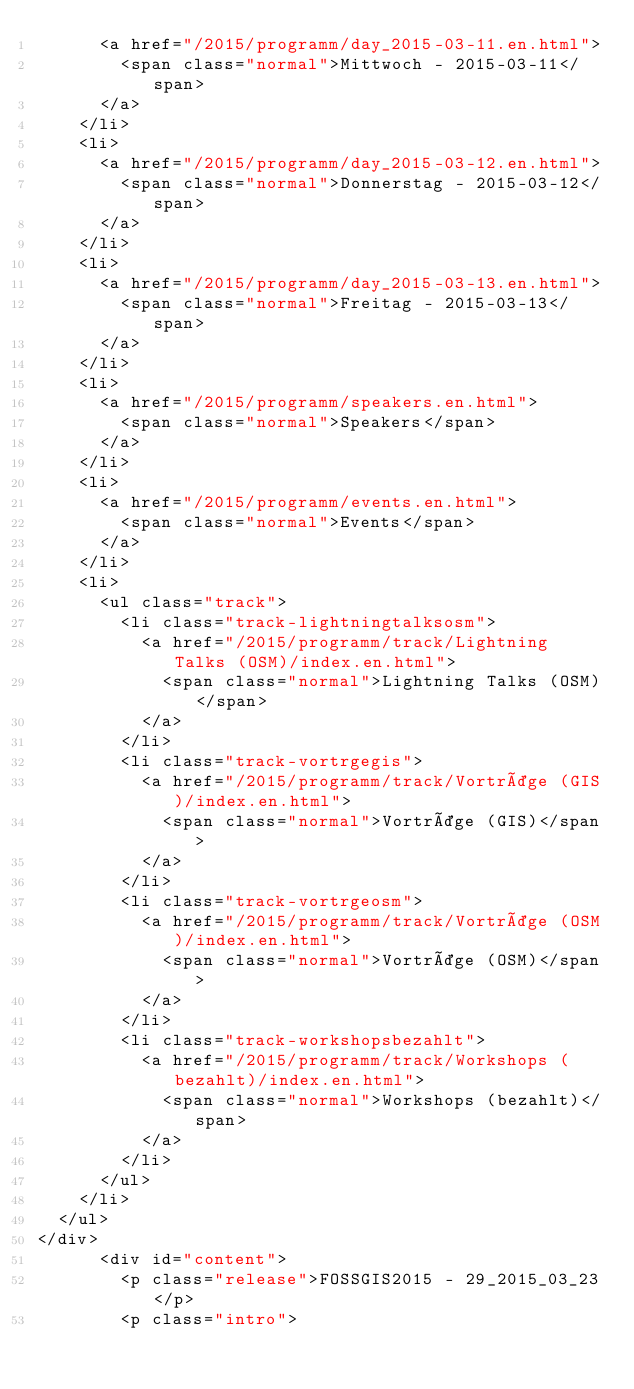Convert code to text. <code><loc_0><loc_0><loc_500><loc_500><_HTML_>      <a href="/2015/programm/day_2015-03-11.en.html">
        <span class="normal">Mittwoch - 2015-03-11</span>
      </a>
    </li>
    <li>
      <a href="/2015/programm/day_2015-03-12.en.html">
        <span class="normal">Donnerstag - 2015-03-12</span>
      </a>
    </li>
    <li>
      <a href="/2015/programm/day_2015-03-13.en.html">
        <span class="normal">Freitag - 2015-03-13</span>
      </a>
    </li>
    <li>
      <a href="/2015/programm/speakers.en.html">
        <span class="normal">Speakers</span>
      </a>
    </li>
    <li>
      <a href="/2015/programm/events.en.html">
        <span class="normal">Events</span>
      </a>
    </li>
    <li>
      <ul class="track">
        <li class="track-lightningtalksosm">
          <a href="/2015/programm/track/Lightning Talks (OSM)/index.en.html">
            <span class="normal">Lightning Talks (OSM)</span>
          </a>
        </li>
        <li class="track-vortrgegis">
          <a href="/2015/programm/track/Vorträge (GIS)/index.en.html">
            <span class="normal">Vorträge (GIS)</span>
          </a>
        </li>
        <li class="track-vortrgeosm">
          <a href="/2015/programm/track/Vorträge (OSM)/index.en.html">
            <span class="normal">Vorträge (OSM)</span>
          </a>
        </li>
        <li class="track-workshopsbezahlt">
          <a href="/2015/programm/track/Workshops (bezahlt)/index.en.html">
            <span class="normal">Workshops (bezahlt)</span>
          </a>
        </li>
      </ul>
    </li>
  </ul>
</div>
      <div id="content">
        <p class="release">FOSSGIS2015 - 29_2015_03_23</p>
        <p class="intro"></code> 